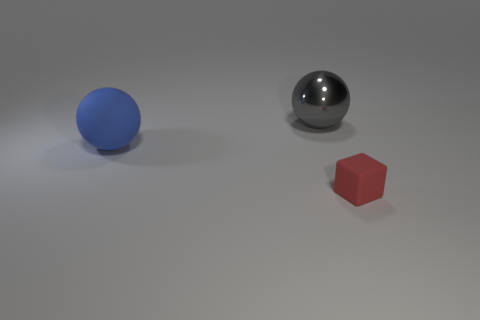There is a matte thing that is in front of the matte thing behind the red thing; what is its shape?
Ensure brevity in your answer.  Cube. Is there anything else that is made of the same material as the gray thing?
Your answer should be compact. No. The red object has what shape?
Give a very brief answer. Cube. What is the size of the sphere right of the big ball in front of the gray object?
Make the answer very short. Large. Are there an equal number of large blue things that are on the left side of the matte sphere and gray spheres right of the small red matte block?
Offer a terse response. Yes. What is the object that is both to the right of the big matte thing and on the left side of the small thing made of?
Give a very brief answer. Metal. There is a blue thing; is its size the same as the object behind the matte ball?
Your response must be concise. Yes. How many other objects are the same color as the shiny sphere?
Your response must be concise. 0. Are there more big metal things to the left of the red cube than tiny purple metal objects?
Ensure brevity in your answer.  Yes. What is the color of the rubber object that is behind the rubber object that is in front of the rubber thing that is on the left side of the red rubber object?
Make the answer very short. Blue. 